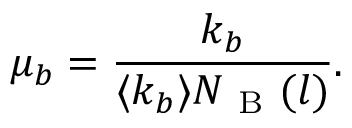Convert formula to latex. <formula><loc_0><loc_0><loc_500><loc_500>\mu _ { b } = \frac { k _ { b } } { \langle k _ { b } \rangle N _ { B } ( l ) } .</formula> 